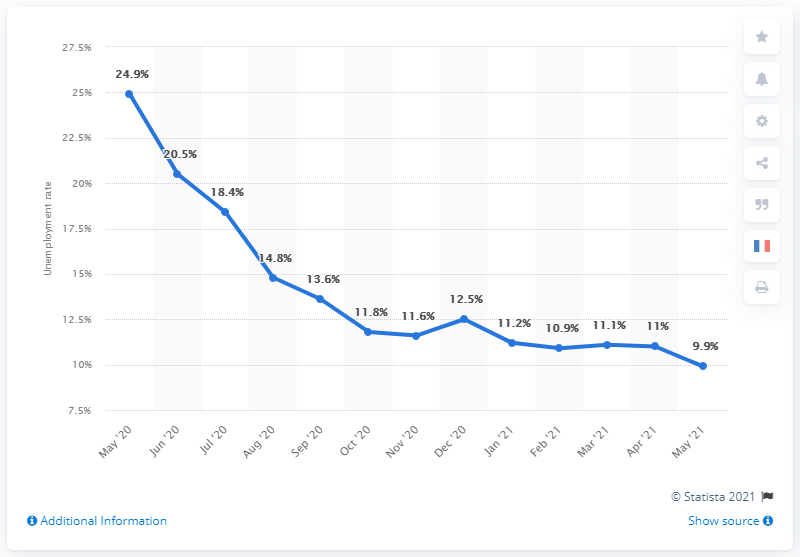Outline some significant characteristics in this image. The unemployment rate in the United States was 9.9% during the period of May 2020 to May 2021. May 2021 was the month with the lowest unemployment rate in the United States during the period of May 2020 to May 2021. 